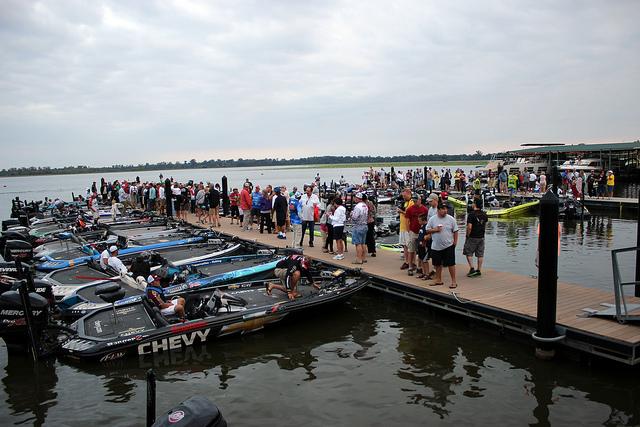Are the boats in this picture likely used for racing?
Concise answer only. Yes. Is there a crowd?
Quick response, please. Yes. Are these boats powered by wind?
Keep it brief. No. Do you think it is cold there?
Answer briefly. No. 